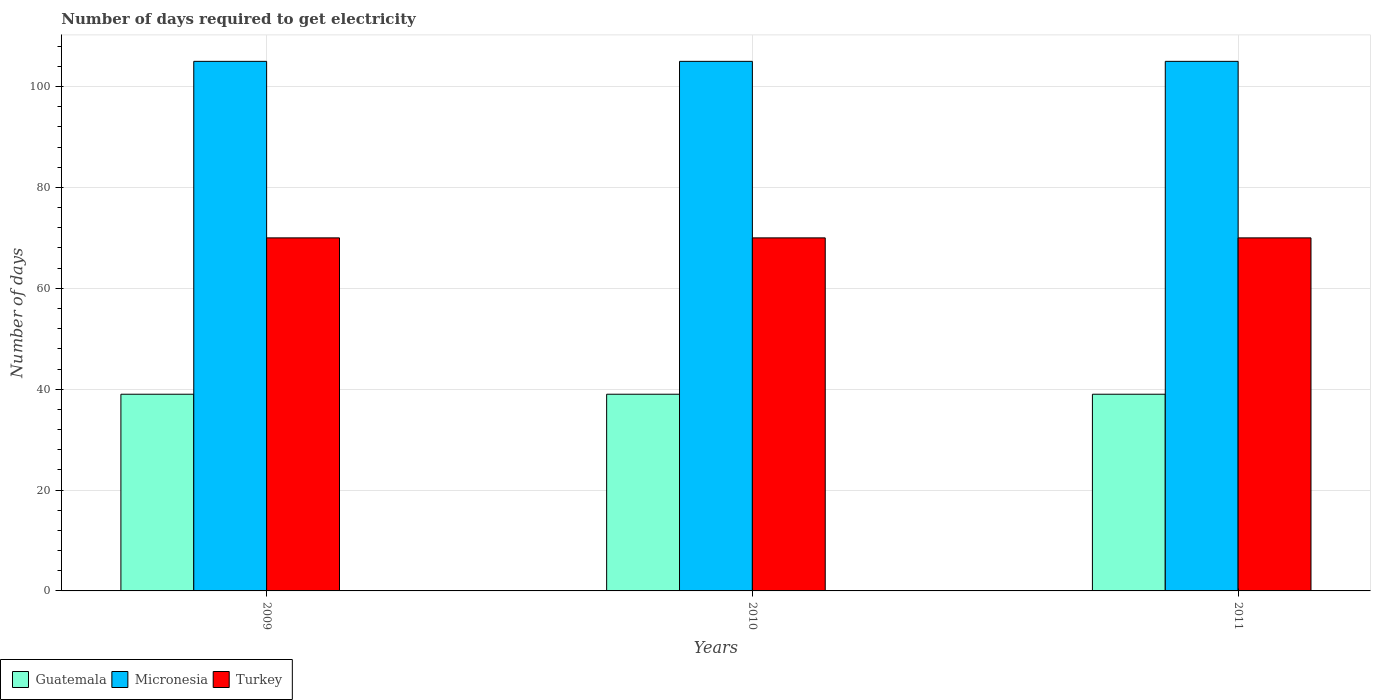Are the number of bars per tick equal to the number of legend labels?
Provide a short and direct response. Yes. How many bars are there on the 3rd tick from the right?
Your answer should be very brief. 3. In how many cases, is the number of bars for a given year not equal to the number of legend labels?
Your response must be concise. 0. What is the number of days required to get electricity in in Guatemala in 2011?
Make the answer very short. 39. Across all years, what is the maximum number of days required to get electricity in in Guatemala?
Provide a succinct answer. 39. Across all years, what is the minimum number of days required to get electricity in in Micronesia?
Offer a very short reply. 105. In which year was the number of days required to get electricity in in Turkey maximum?
Make the answer very short. 2009. In which year was the number of days required to get electricity in in Micronesia minimum?
Ensure brevity in your answer.  2009. What is the total number of days required to get electricity in in Turkey in the graph?
Make the answer very short. 210. What is the difference between the number of days required to get electricity in in Micronesia in 2010 and the number of days required to get electricity in in Turkey in 2009?
Offer a terse response. 35. In the year 2010, what is the difference between the number of days required to get electricity in in Guatemala and number of days required to get electricity in in Turkey?
Give a very brief answer. -31. In how many years, is the number of days required to get electricity in in Turkey greater than 32 days?
Your response must be concise. 3. What is the ratio of the number of days required to get electricity in in Guatemala in 2010 to that in 2011?
Give a very brief answer. 1. Is the number of days required to get electricity in in Micronesia in 2009 less than that in 2011?
Provide a short and direct response. No. In how many years, is the number of days required to get electricity in in Micronesia greater than the average number of days required to get electricity in in Micronesia taken over all years?
Ensure brevity in your answer.  0. What does the 1st bar from the left in 2010 represents?
Your answer should be compact. Guatemala. What does the 2nd bar from the right in 2009 represents?
Provide a short and direct response. Micronesia. Is it the case that in every year, the sum of the number of days required to get electricity in in Guatemala and number of days required to get electricity in in Micronesia is greater than the number of days required to get electricity in in Turkey?
Offer a terse response. Yes. How many bars are there?
Offer a terse response. 9. Are all the bars in the graph horizontal?
Your answer should be very brief. No. What is the difference between two consecutive major ticks on the Y-axis?
Offer a terse response. 20. Are the values on the major ticks of Y-axis written in scientific E-notation?
Make the answer very short. No. Does the graph contain any zero values?
Your answer should be very brief. No. Does the graph contain grids?
Your response must be concise. Yes. Where does the legend appear in the graph?
Give a very brief answer. Bottom left. What is the title of the graph?
Your response must be concise. Number of days required to get electricity. What is the label or title of the X-axis?
Your response must be concise. Years. What is the label or title of the Y-axis?
Your answer should be compact. Number of days. What is the Number of days of Guatemala in 2009?
Provide a short and direct response. 39. What is the Number of days in Micronesia in 2009?
Offer a terse response. 105. What is the Number of days of Turkey in 2009?
Your response must be concise. 70. What is the Number of days of Guatemala in 2010?
Ensure brevity in your answer.  39. What is the Number of days of Micronesia in 2010?
Your answer should be very brief. 105. What is the Number of days of Turkey in 2010?
Provide a short and direct response. 70. What is the Number of days of Micronesia in 2011?
Your answer should be very brief. 105. What is the Number of days in Turkey in 2011?
Offer a very short reply. 70. Across all years, what is the maximum Number of days of Guatemala?
Your answer should be compact. 39. Across all years, what is the maximum Number of days in Micronesia?
Provide a short and direct response. 105. Across all years, what is the maximum Number of days in Turkey?
Provide a succinct answer. 70. Across all years, what is the minimum Number of days of Micronesia?
Offer a very short reply. 105. Across all years, what is the minimum Number of days in Turkey?
Give a very brief answer. 70. What is the total Number of days in Guatemala in the graph?
Your answer should be very brief. 117. What is the total Number of days of Micronesia in the graph?
Offer a terse response. 315. What is the total Number of days in Turkey in the graph?
Your answer should be compact. 210. What is the difference between the Number of days in Micronesia in 2009 and that in 2010?
Your answer should be compact. 0. What is the difference between the Number of days of Turkey in 2009 and that in 2010?
Make the answer very short. 0. What is the difference between the Number of days of Guatemala in 2009 and that in 2011?
Provide a succinct answer. 0. What is the difference between the Number of days of Micronesia in 2010 and that in 2011?
Give a very brief answer. 0. What is the difference between the Number of days in Guatemala in 2009 and the Number of days in Micronesia in 2010?
Provide a succinct answer. -66. What is the difference between the Number of days in Guatemala in 2009 and the Number of days in Turkey in 2010?
Provide a succinct answer. -31. What is the difference between the Number of days in Micronesia in 2009 and the Number of days in Turkey in 2010?
Make the answer very short. 35. What is the difference between the Number of days in Guatemala in 2009 and the Number of days in Micronesia in 2011?
Keep it short and to the point. -66. What is the difference between the Number of days of Guatemala in 2009 and the Number of days of Turkey in 2011?
Provide a short and direct response. -31. What is the difference between the Number of days of Micronesia in 2009 and the Number of days of Turkey in 2011?
Ensure brevity in your answer.  35. What is the difference between the Number of days in Guatemala in 2010 and the Number of days in Micronesia in 2011?
Your response must be concise. -66. What is the difference between the Number of days in Guatemala in 2010 and the Number of days in Turkey in 2011?
Offer a very short reply. -31. What is the average Number of days of Guatemala per year?
Your response must be concise. 39. What is the average Number of days in Micronesia per year?
Make the answer very short. 105. What is the average Number of days in Turkey per year?
Provide a short and direct response. 70. In the year 2009, what is the difference between the Number of days in Guatemala and Number of days in Micronesia?
Make the answer very short. -66. In the year 2009, what is the difference between the Number of days in Guatemala and Number of days in Turkey?
Keep it short and to the point. -31. In the year 2009, what is the difference between the Number of days of Micronesia and Number of days of Turkey?
Your answer should be very brief. 35. In the year 2010, what is the difference between the Number of days in Guatemala and Number of days in Micronesia?
Offer a terse response. -66. In the year 2010, what is the difference between the Number of days of Guatemala and Number of days of Turkey?
Provide a succinct answer. -31. In the year 2011, what is the difference between the Number of days of Guatemala and Number of days of Micronesia?
Your answer should be compact. -66. In the year 2011, what is the difference between the Number of days in Guatemala and Number of days in Turkey?
Give a very brief answer. -31. In the year 2011, what is the difference between the Number of days in Micronesia and Number of days in Turkey?
Your response must be concise. 35. What is the ratio of the Number of days in Guatemala in 2009 to that in 2010?
Make the answer very short. 1. What is the ratio of the Number of days in Micronesia in 2009 to that in 2011?
Provide a short and direct response. 1. What is the ratio of the Number of days of Guatemala in 2010 to that in 2011?
Ensure brevity in your answer.  1. What is the ratio of the Number of days of Micronesia in 2010 to that in 2011?
Offer a very short reply. 1. What is the ratio of the Number of days in Turkey in 2010 to that in 2011?
Ensure brevity in your answer.  1. What is the difference between the highest and the second highest Number of days of Guatemala?
Provide a succinct answer. 0. What is the difference between the highest and the second highest Number of days of Micronesia?
Provide a short and direct response. 0. What is the difference between the highest and the lowest Number of days in Guatemala?
Make the answer very short. 0. What is the difference between the highest and the lowest Number of days of Turkey?
Your response must be concise. 0. 